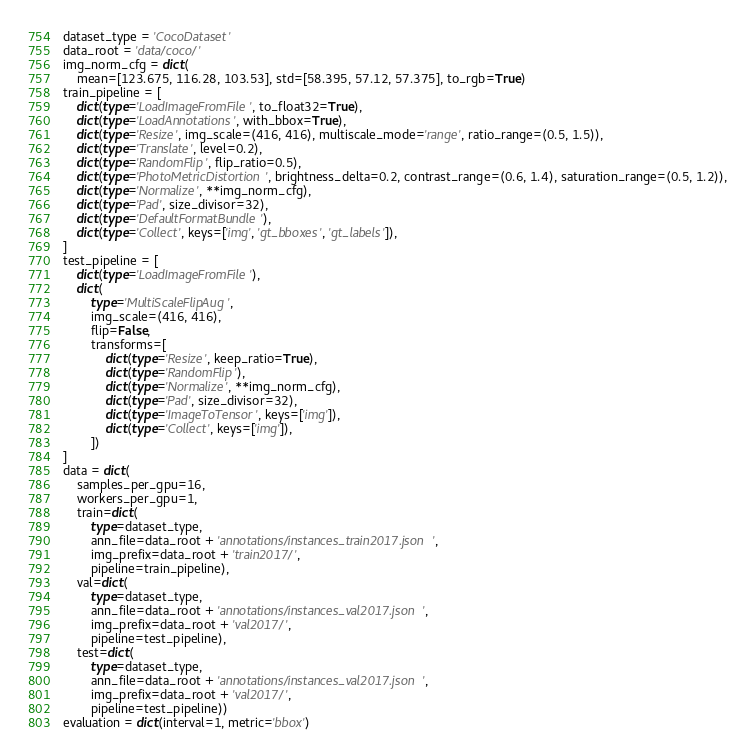Convert code to text. <code><loc_0><loc_0><loc_500><loc_500><_Python_>dataset_type = 'CocoDataset'
data_root = 'data/coco/'
img_norm_cfg = dict(
    mean=[123.675, 116.28, 103.53], std=[58.395, 57.12, 57.375], to_rgb=True)
train_pipeline = [
    dict(type='LoadImageFromFile', to_float32=True),
    dict(type='LoadAnnotations', with_bbox=True),
    dict(type='Resize', img_scale=(416, 416), multiscale_mode='range', ratio_range=(0.5, 1.5)),
    dict(type='Translate', level=0.2),
    dict(type='RandomFlip', flip_ratio=0.5),
    dict(type='PhotoMetricDistortion', brightness_delta=0.2, contrast_range=(0.6, 1.4), saturation_range=(0.5, 1.2)),
    dict(type='Normalize', **img_norm_cfg),
    dict(type='Pad', size_divisor=32),
    dict(type='DefaultFormatBundle'),
    dict(type='Collect', keys=['img', 'gt_bboxes', 'gt_labels']),
]
test_pipeline = [
    dict(type='LoadImageFromFile'),
    dict(
        type='MultiScaleFlipAug',
        img_scale=(416, 416),
        flip=False,
        transforms=[
            dict(type='Resize', keep_ratio=True),
            dict(type='RandomFlip'),
            dict(type='Normalize', **img_norm_cfg),
            dict(type='Pad', size_divisor=32),
            dict(type='ImageToTensor', keys=['img']),
            dict(type='Collect', keys=['img']),
        ])
]
data = dict(
    samples_per_gpu=16,
    workers_per_gpu=1,
    train=dict(
        type=dataset_type,
        ann_file=data_root + 'annotations/instances_train2017.json',
        img_prefix=data_root + 'train2017/',
        pipeline=train_pipeline),
    val=dict(
        type=dataset_type,
        ann_file=data_root + 'annotations/instances_val2017.json',
        img_prefix=data_root + 'val2017/',
        pipeline=test_pipeline),
    test=dict(
        type=dataset_type,
        ann_file=data_root + 'annotations/instances_val2017.json',
        img_prefix=data_root + 'val2017/',
        pipeline=test_pipeline))
evaluation = dict(interval=1, metric='bbox')
</code> 